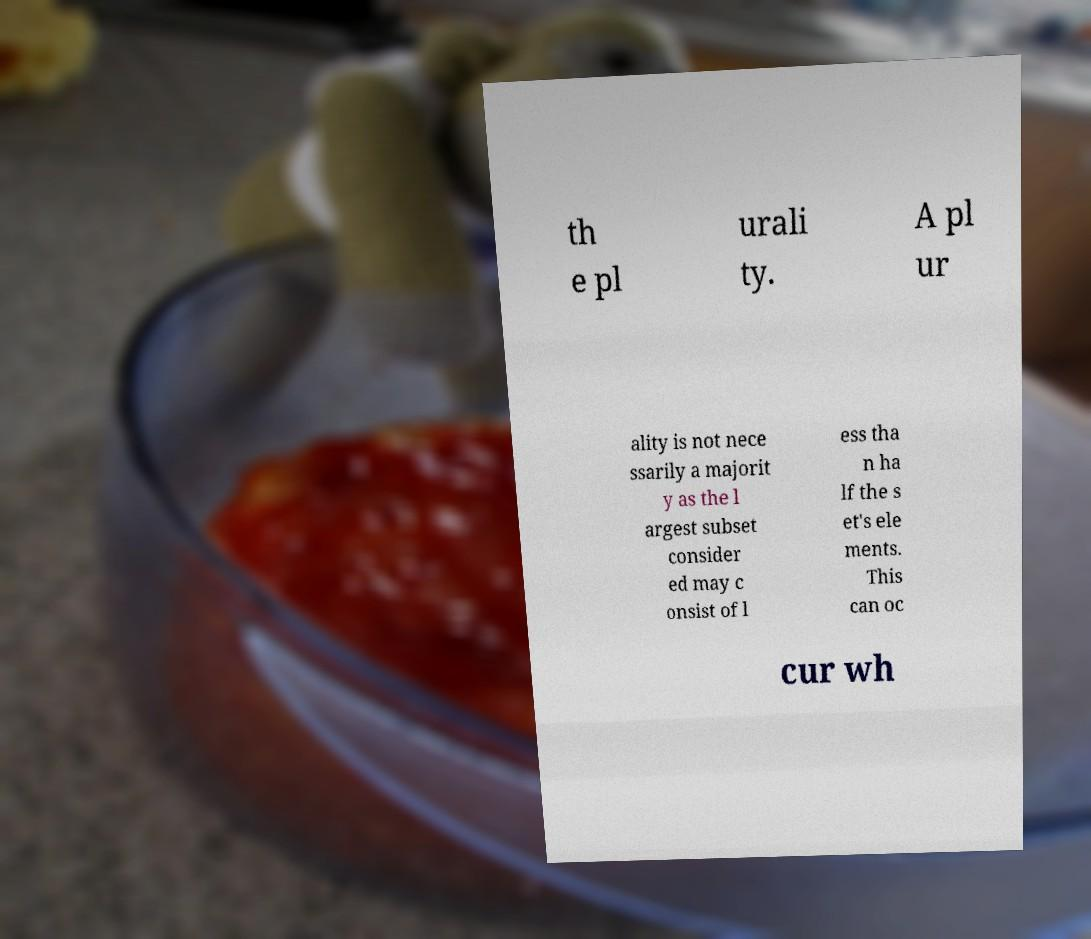Can you read and provide the text displayed in the image?This photo seems to have some interesting text. Can you extract and type it out for me? th e pl urali ty. A pl ur ality is not nece ssarily a majorit y as the l argest subset consider ed may c onsist of l ess tha n ha lf the s et's ele ments. This can oc cur wh 